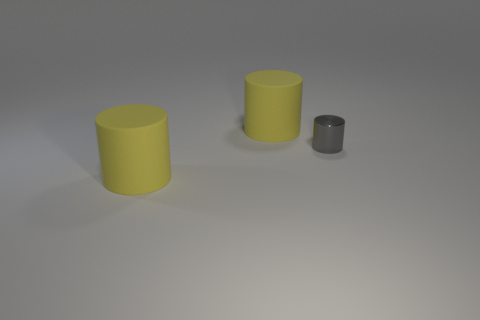Are there any big purple rubber cylinders? Based on the image, there are no purple cylinders present. There are two large yellow cylinders and one smaller gray cylinder. It is not possible to definitively determine the material of the cylinders from the image alone. 